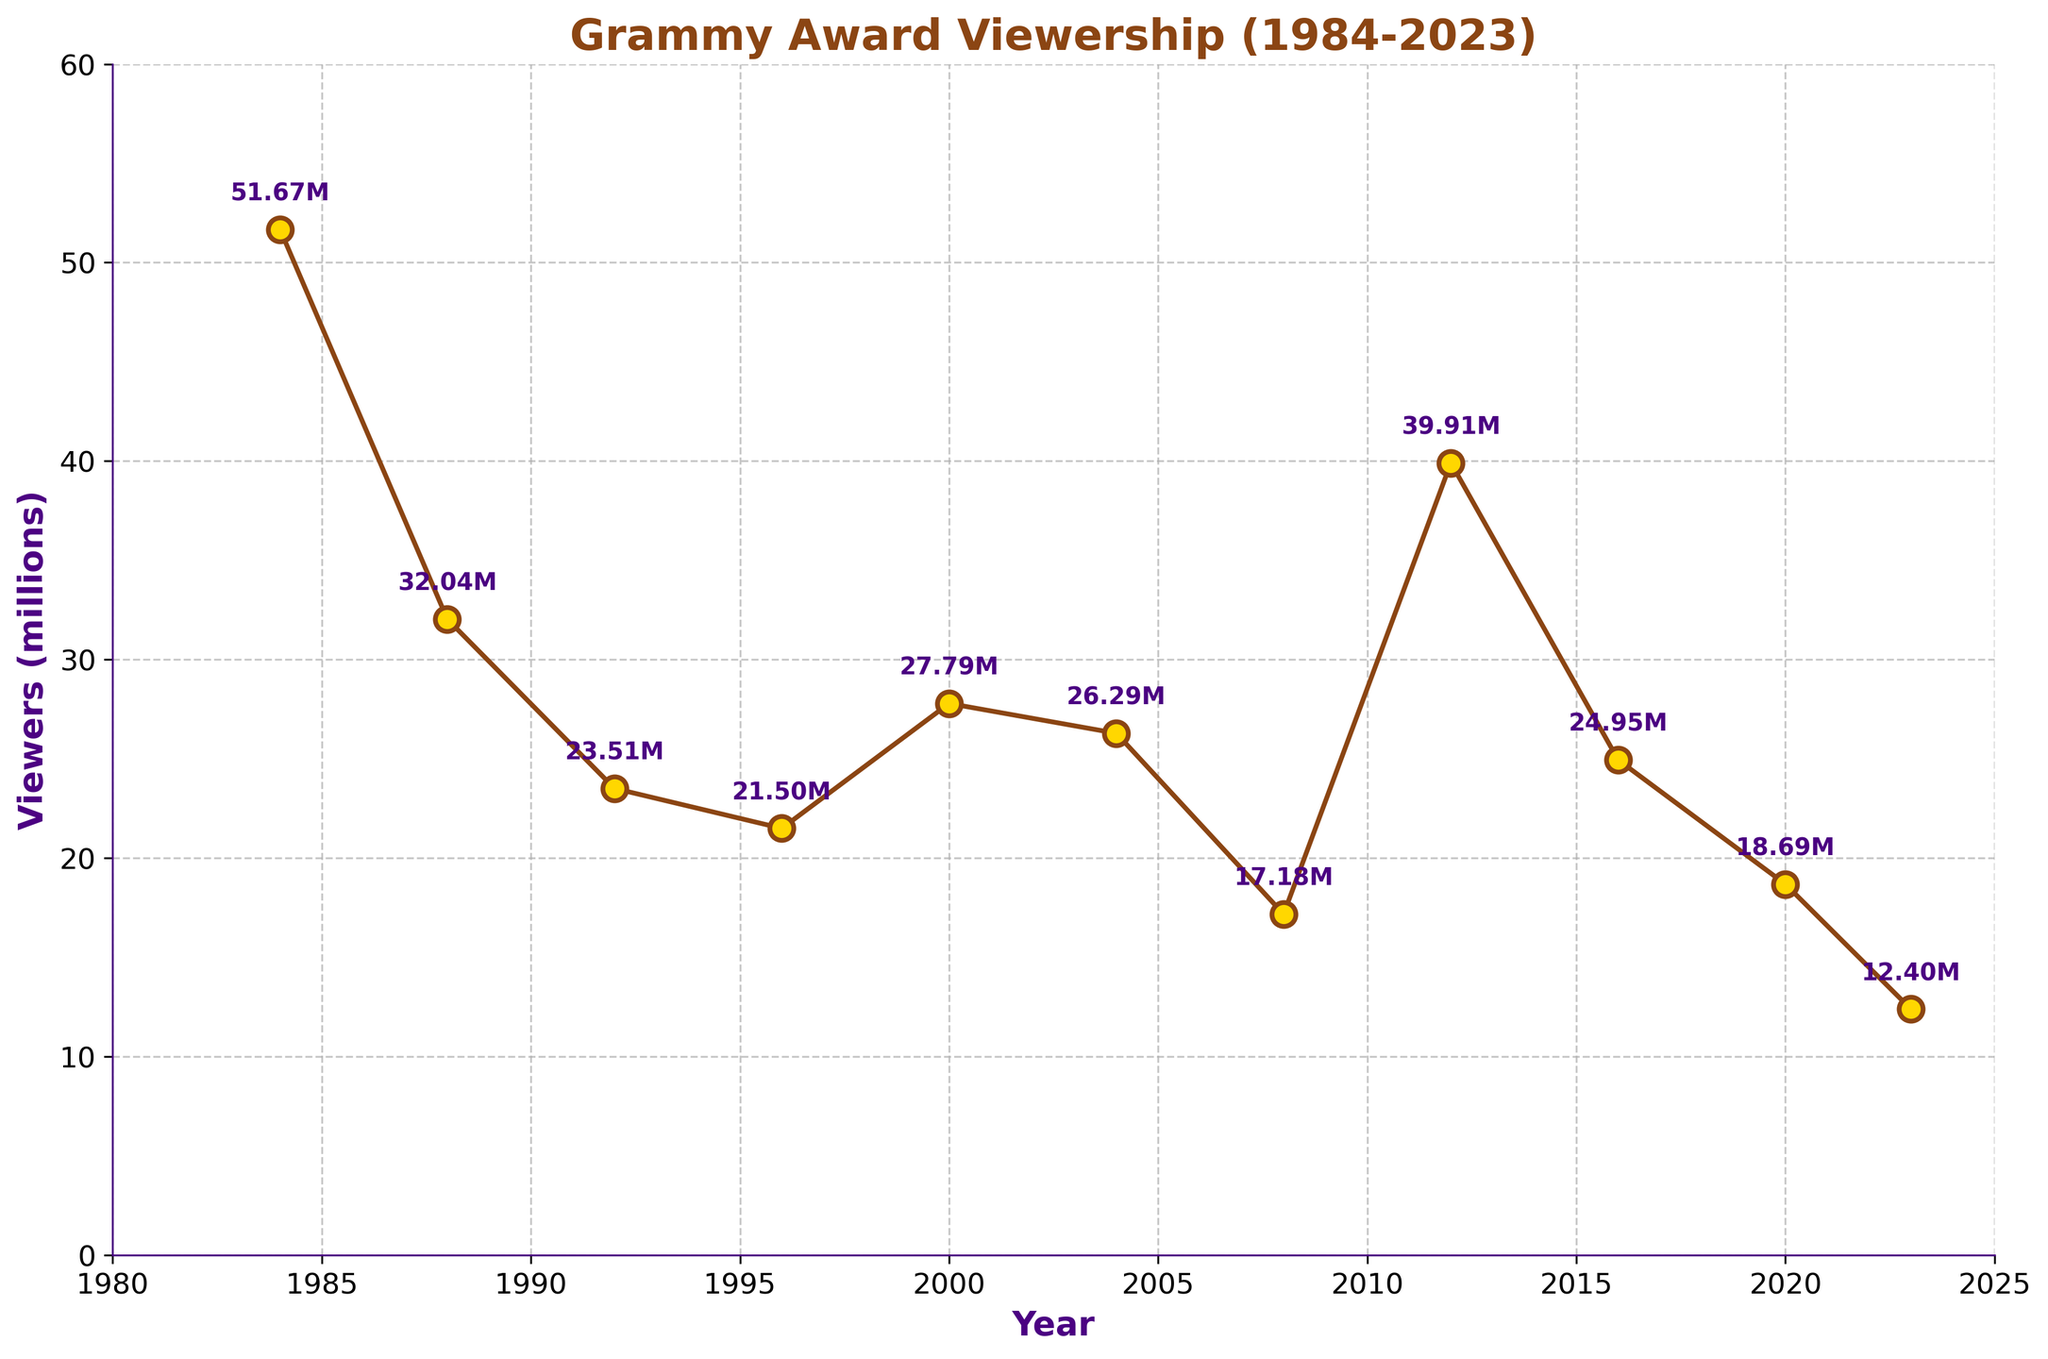What was the viewership in the year with the highest ratings? Locate the peak on the line chart and read the corresponding value. The highest point occurs in 1984 with 51.67 million viewers.
Answer: 51.67 million Which year had lower viewership: 1996 or 2000? Identify the data points for 1996 and 2000. In 1996, the viewership was 21.50 million, and in 2000, it was 27.79 million. Hence, 1996 had lower viewership.
Answer: 1996 What is the general trend in viewership from 1984 to 2023? Observe the overall progression of the line. Starting from a high point in 1984, the viewership shows a decreasing trend with occasional increases, ending at a low point in 2023.
Answer: Decreasing What is the average viewership over the given years? Sum the viewership values for all the given years: 51.67 + 32.04 + 23.51 + 21.50 + 27.79 + 26.29 + 17.18 + 39.91 + 24.95 + 18.69 + 12.40 = 295.93 million. Divide by the number of years (11): 295.93 / 11 ≈ 26.90 million.
Answer: 26.90 million Which two consecutive years had the largest drop in viewership? Examine each consecutive year pair for the greatest decline. Comparing differences: 
    
- 1984-1988: 51.67 - 32.04 = 19.63 million
- 1988-1992: 32.04 - 23.51 = 8.53 million
- 1992-1996: 23.51 - 21.50 = 2.01 million
- 1996-2000: -6.29 million (increase)
- 2000-2004: 27.79 - 26.29 = 1.50 million
- 2004-2008: 26.29 - 17.18 = 9.11 million
- 2008-2012: -22.73 million (increase)
- 2012-2016: 39.91 - 24.95 = 14.96 million
- 2016-2020: 24.95 - 18.69 = 6.26 million
- 2020-2023: 18.69 - 12.40 = 6.29 million
    
The largest drop is seen between 1984 and 1988, with a decrease of 19.63 million viewers.
Answer: 1984-1988 How many times did the viewership exceed 25 million viewers? Count the number of data points where viewership exceeded 25 million. The years are: 1984, 2000, 2004, 2012, and 2016. This happens 5 times.
Answer: 5 Which year had nearly half the viewership of 1984? Calculate half of the 1984 viewership: 51.67 / 2 ≈ 25.84 million. The closest year is 2016 with 24.95 million viewers.
Answer: 2016 